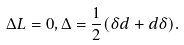<formula> <loc_0><loc_0><loc_500><loc_500>\Delta L = 0 , \Delta = \frac { 1 } { 2 } ( \delta d + d \delta ) .</formula> 